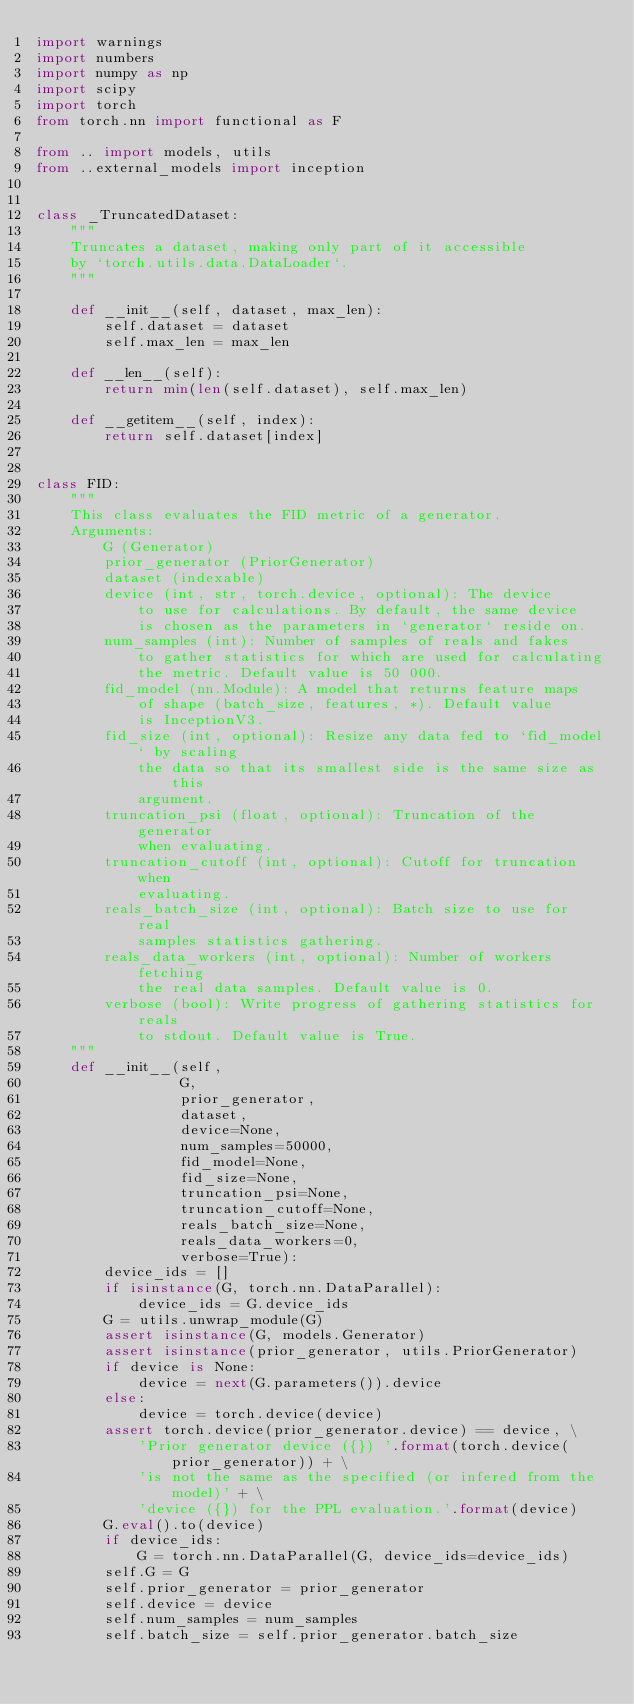Convert code to text. <code><loc_0><loc_0><loc_500><loc_500><_Python_>import warnings
import numbers
import numpy as np
import scipy
import torch
from torch.nn import functional as F

from .. import models, utils
from ..external_models import inception


class _TruncatedDataset:
    """
    Truncates a dataset, making only part of it accessible
    by `torch.utils.data.DataLoader`.
    """

    def __init__(self, dataset, max_len):
        self.dataset = dataset
        self.max_len = max_len

    def __len__(self):
        return min(len(self.dataset), self.max_len)

    def __getitem__(self, index):
        return self.dataset[index]


class FID:
    """
    This class evaluates the FID metric of a generator.
    Arguments:
        G (Generator)
        prior_generator (PriorGenerator)
        dataset (indexable)
        device (int, str, torch.device, optional): The device
            to use for calculations. By default, the same device
            is chosen as the parameters in `generator` reside on.
        num_samples (int): Number of samples of reals and fakes
            to gather statistics for which are used for calculating
            the metric. Default value is 50 000.
        fid_model (nn.Module): A model that returns feature maps
            of shape (batch_size, features, *). Default value
            is InceptionV3.
        fid_size (int, optional): Resize any data fed to `fid_model` by scaling
            the data so that its smallest side is the same size as this
            argument.
        truncation_psi (float, optional): Truncation of the generator
            when evaluating.
        truncation_cutoff (int, optional): Cutoff for truncation when
            evaluating.
        reals_batch_size (int, optional): Batch size to use for real
            samples statistics gathering.
        reals_data_workers (int, optional): Number of workers fetching
            the real data samples. Default value is 0.
        verbose (bool): Write progress of gathering statistics for reals
            to stdout. Default value is True.
    """
    def __init__(self,
                 G,
                 prior_generator,
                 dataset,
                 device=None,
                 num_samples=50000,
                 fid_model=None,
                 fid_size=None,
                 truncation_psi=None,
                 truncation_cutoff=None,
                 reals_batch_size=None,
                 reals_data_workers=0,
                 verbose=True):
        device_ids = []
        if isinstance(G, torch.nn.DataParallel):
            device_ids = G.device_ids
        G = utils.unwrap_module(G)
        assert isinstance(G, models.Generator)
        assert isinstance(prior_generator, utils.PriorGenerator)
        if device is None:
            device = next(G.parameters()).device
        else:
            device = torch.device(device)
        assert torch.device(prior_generator.device) == device, \
            'Prior generator device ({}) '.format(torch.device(prior_generator)) + \
            'is not the same as the specified (or infered from the model)' + \
            'device ({}) for the PPL evaluation.'.format(device)
        G.eval().to(device)
        if device_ids:
            G = torch.nn.DataParallel(G, device_ids=device_ids)
        self.G = G
        self.prior_generator = prior_generator
        self.device = device
        self.num_samples = num_samples
        self.batch_size = self.prior_generator.batch_size</code> 